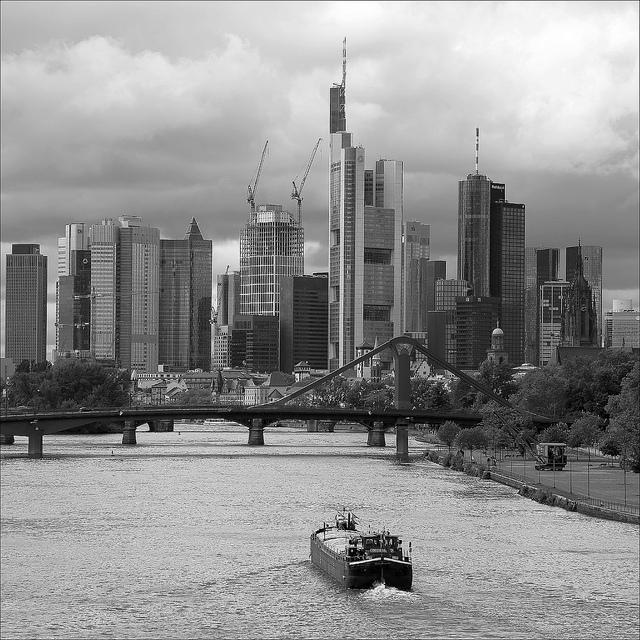How many cranes are extending into the sky in the background?
Give a very brief answer. 2. How many women on the bill board are touching their head?
Give a very brief answer. 0. 